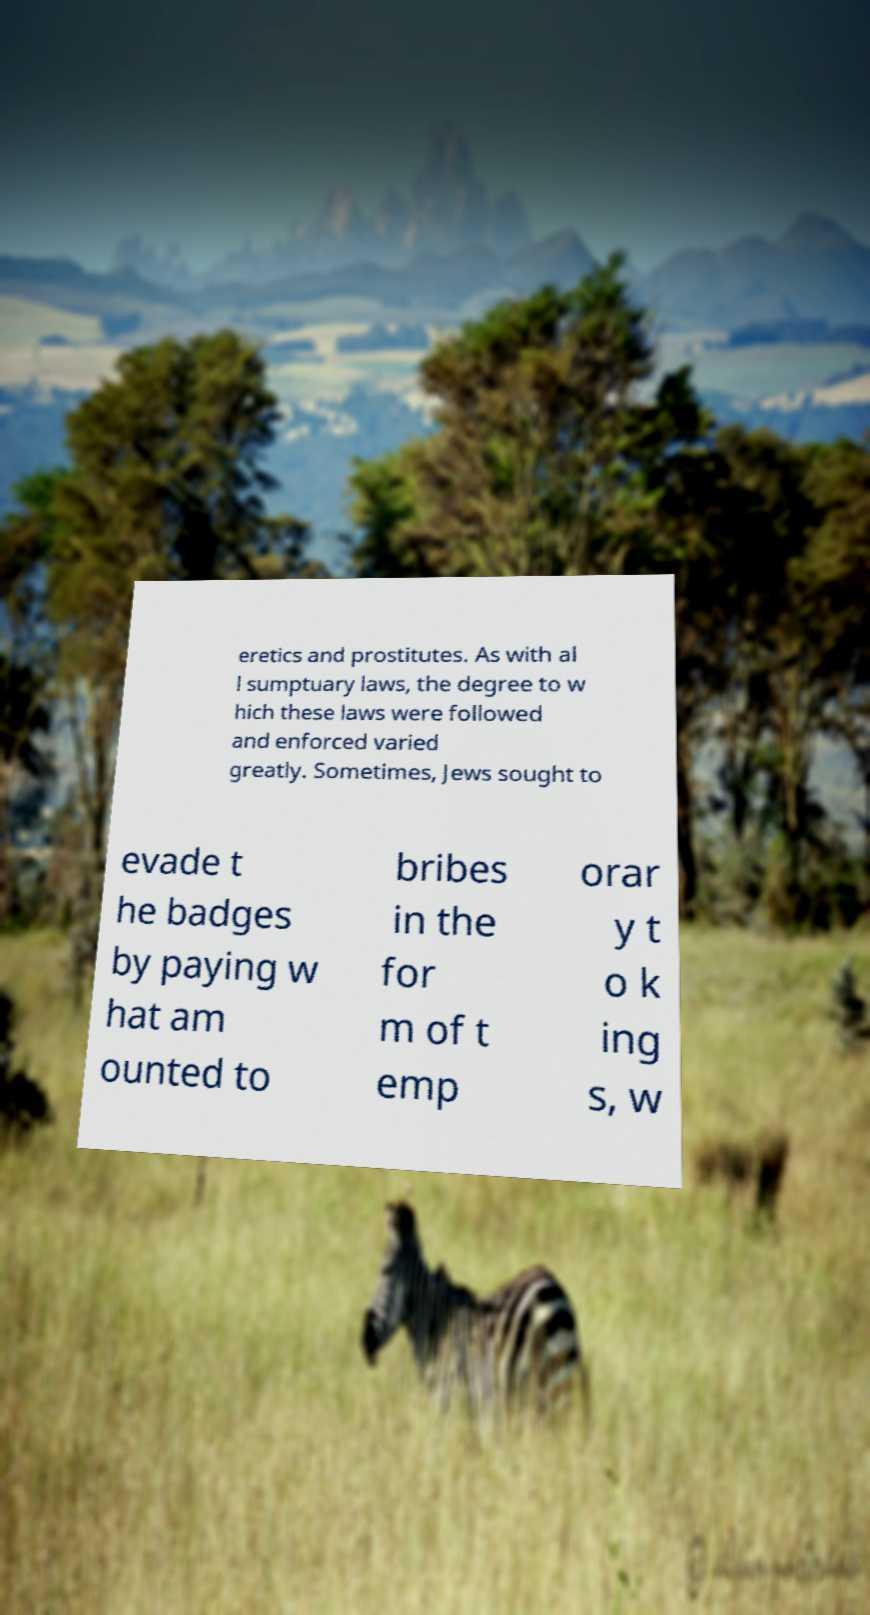Can you accurately transcribe the text from the provided image for me? eretics and prostitutes. As with al l sumptuary laws, the degree to w hich these laws were followed and enforced varied greatly. Sometimes, Jews sought to evade t he badges by paying w hat am ounted to bribes in the for m of t emp orar y t o k ing s, w 